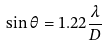Convert formula to latex. <formula><loc_0><loc_0><loc_500><loc_500>\sin \theta = 1 . 2 2 \frac { \lambda } { D }</formula> 